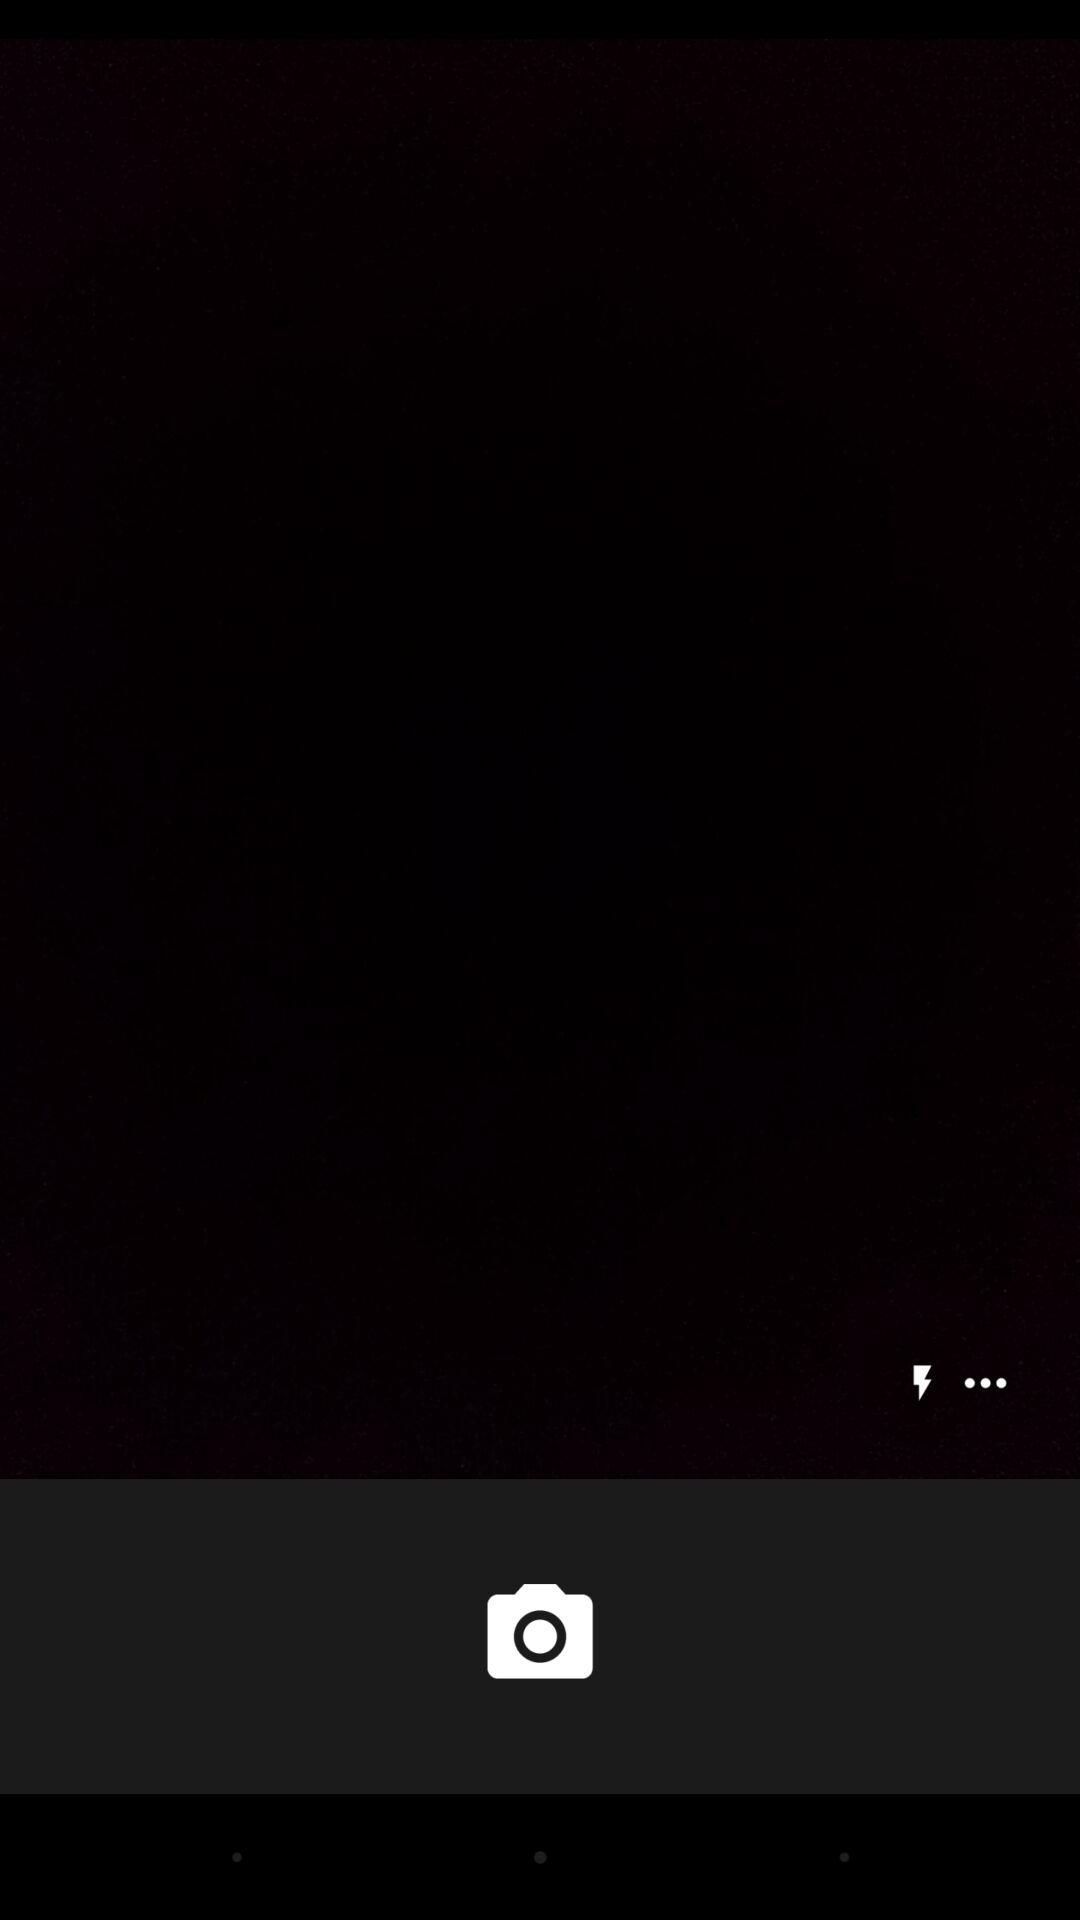How many more dots are there than lightning bolts?
Answer the question using a single word or phrase. 2 